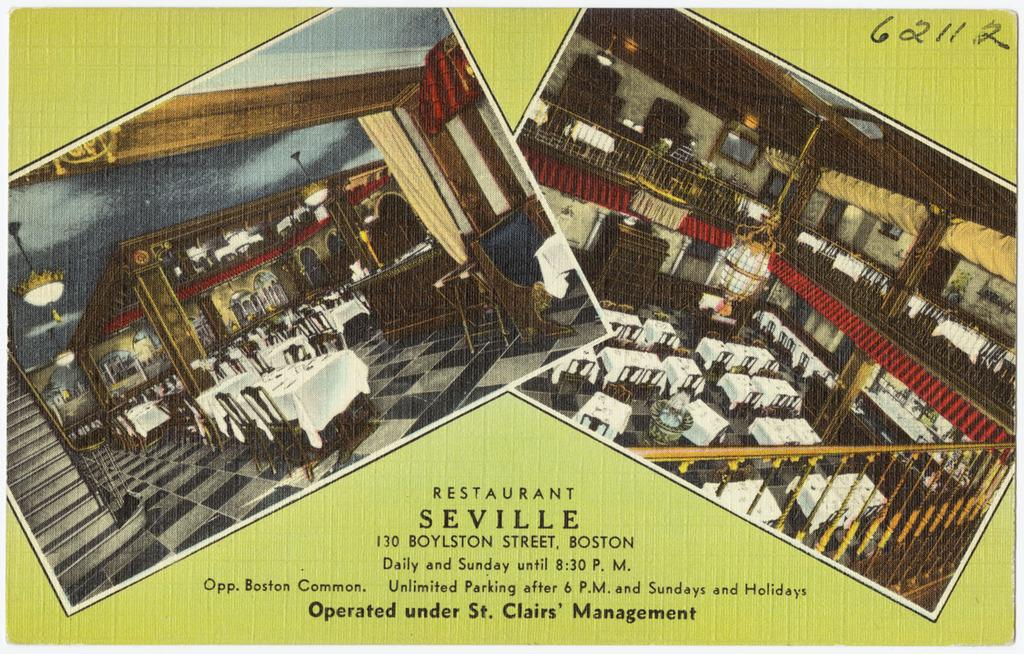<image>
Render a clear and concise summary of the photo. An ad for the Restaurant Seville states it is run by St. Clairs' Management. 